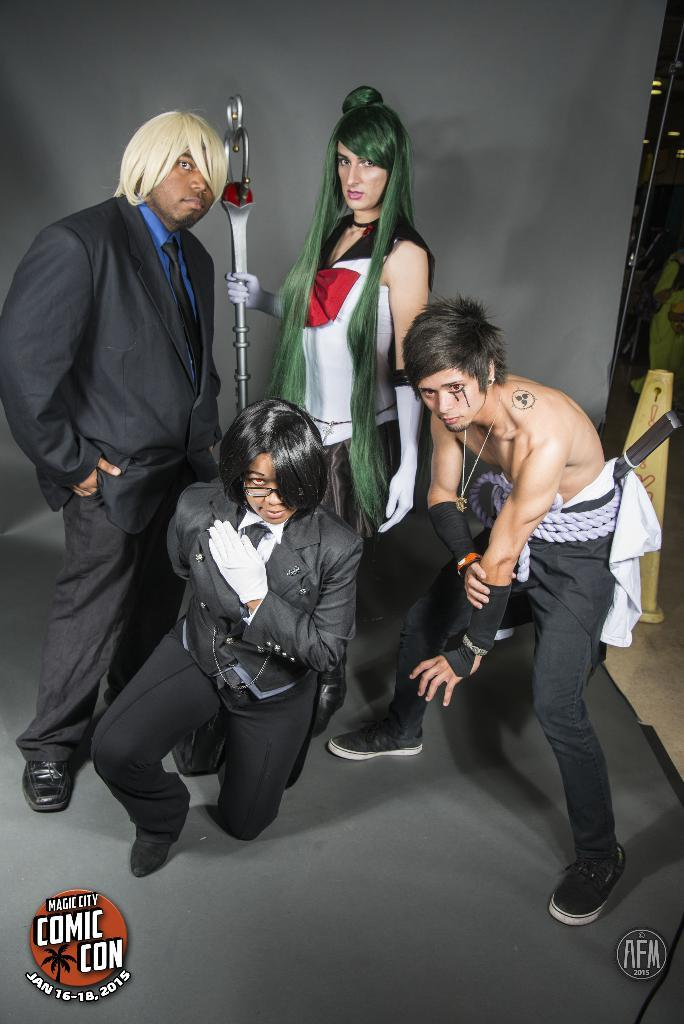What is the main subject of the image? The main subject of the image is a group of people. Can you describe the attire of one of the individuals in the group? One person is wearing a black color blazer and a blue color shirt. What is the color of the background in the image? The background of the image is gray in color. What type of force can be seen pushing the trees into the ground in the image? There are no trees or any force pushing them into the ground in the image. 